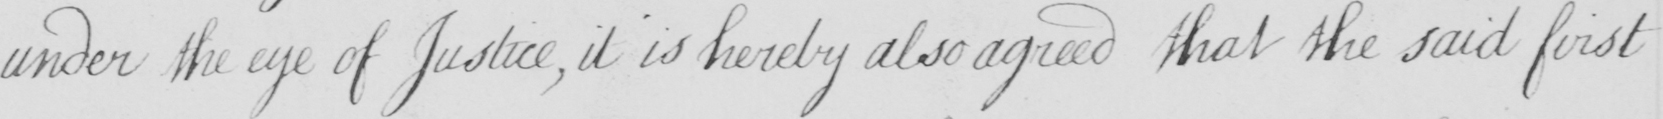Can you read and transcribe this handwriting? under the eye of Justice , it is hereby also agreed that the said first 